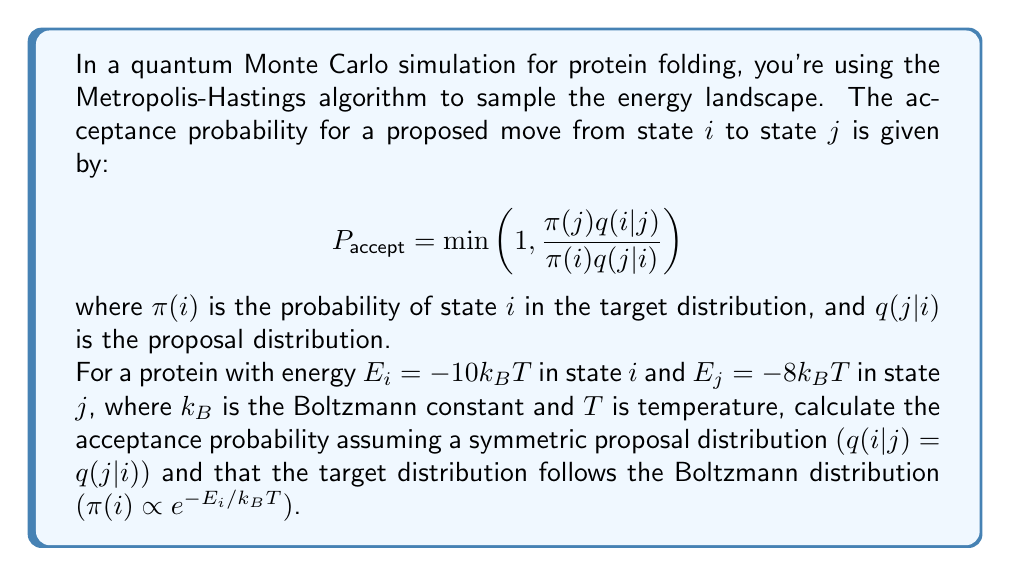Give your solution to this math problem. Let's approach this step-by-step:

1) First, recall that for the Boltzmann distribution:
   $$\pi(i) \propto e^{-E_i/k_BT}$$

2) Given that $q(i|j) = q(j|i)$ (symmetric proposal distribution), these terms cancel out in the acceptance probability formula:
   $$P_{accept} = \min\left(1, \frac{\pi(j)}{\pi(i)}\right)$$

3) Now, let's calculate the ratio $\frac{\pi(j)}{\pi(i)}$:
   $$\frac{\pi(j)}{\pi(i)} = \frac{e^{-E_j/k_BT}}{e^{-E_i/k_BT}}$$

4) Substituting the given energies:
   $$\frac{\pi(j)}{\pi(i)} = \frac{e^{-(-8k_BT)/k_BT}}{e^{-(-10k_BT)/k_BT}} = \frac{e^8}{e^{10}}$$

5) Simplify:
   $$\frac{\pi(j)}{\pi(i)} = e^{-2} \approx 0.1353$$

6) Since this ratio is less than 1, it will be the acceptance probability:
   $$P_{accept} = \min(1, 0.1353) = 0.1353$$

Therefore, the acceptance probability is approximately 0.1353 or 13.53%.
Answer: $0.1353$ 